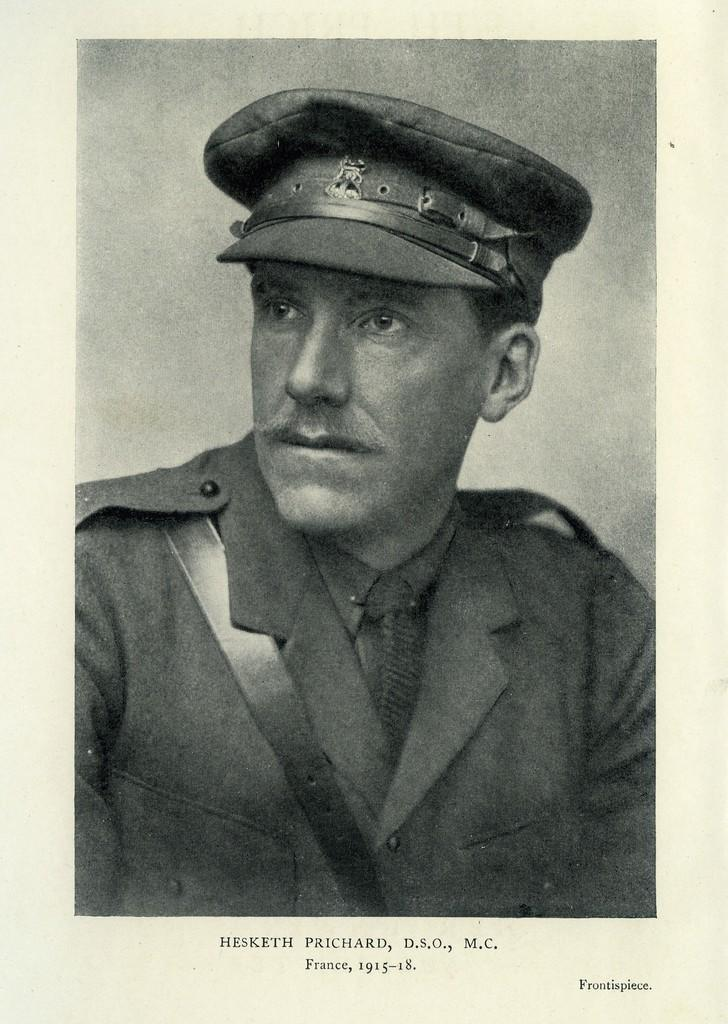What is the main subject of the image? There is a photograph of a man in the image. What type of pin is the squirrel wearing on its tail in the image? There is no squirrel or pin present in the image; it features a photograph of a man. 